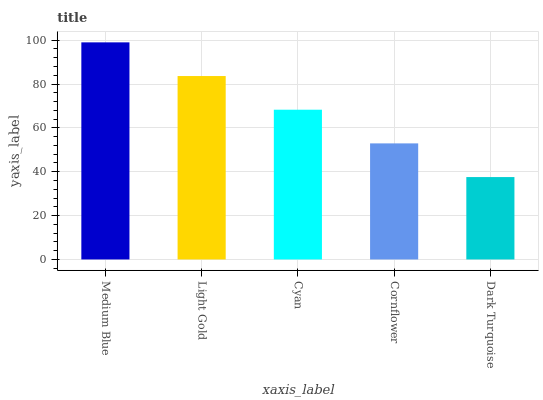Is Dark Turquoise the minimum?
Answer yes or no. Yes. Is Medium Blue the maximum?
Answer yes or no. Yes. Is Light Gold the minimum?
Answer yes or no. No. Is Light Gold the maximum?
Answer yes or no. No. Is Medium Blue greater than Light Gold?
Answer yes or no. Yes. Is Light Gold less than Medium Blue?
Answer yes or no. Yes. Is Light Gold greater than Medium Blue?
Answer yes or no. No. Is Medium Blue less than Light Gold?
Answer yes or no. No. Is Cyan the high median?
Answer yes or no. Yes. Is Cyan the low median?
Answer yes or no. Yes. Is Dark Turquoise the high median?
Answer yes or no. No. Is Medium Blue the low median?
Answer yes or no. No. 